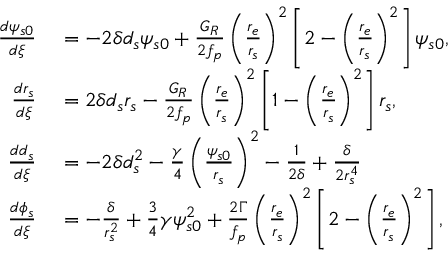Convert formula to latex. <formula><loc_0><loc_0><loc_500><loc_500>\begin{array} { r l } { \frac { d \psi _ { s 0 } } { d \xi } } & = - 2 \delta d _ { s } \psi _ { s 0 } + \frac { G _ { R } } { 2 f _ { p } } \left ( \frac { r _ { e } } { r _ { s } } \right ) ^ { 2 } \left [ 2 - \left ( \frac { r _ { e } } { r _ { s } } \right ) ^ { 2 } \right ] \psi _ { s 0 } , } \\ { \frac { d r _ { s } } { d \xi } } & = 2 \delta d _ { s } r _ { s } - \frac { G _ { R } } { 2 f _ { p } } \left ( \frac { r _ { e } } { r _ { s } } \right ) ^ { 2 } \left [ 1 - \left ( \frac { r _ { e } } { r _ { s } } \right ) ^ { 2 } \right ] r _ { s } , } \\ { \frac { d d _ { s } } { d \xi } } & = - 2 \delta d _ { s } ^ { 2 } - \frac { \gamma } { 4 } \left ( \frac { \psi _ { s 0 } } { r _ { s } } \right ) ^ { 2 } - \frac { 1 } { 2 \delta } + \frac { \delta } { 2 r _ { s } ^ { 4 } } } \\ { \frac { d \phi _ { s } } { d \xi } } & = - \frac { \delta } { r _ { s } ^ { 2 } } + \frac { 3 } { 4 } \gamma \psi _ { s 0 } ^ { 2 } + \frac { 2 \Gamma } { f _ { p } } \left ( \frac { r _ { e } } { r _ { s } } \right ) ^ { 2 } \left [ 2 - \left ( \frac { r _ { e } } { r _ { s } } \right ) ^ { 2 } \right ] , } \end{array}</formula> 